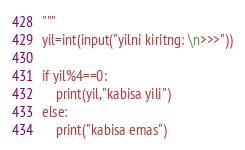Convert code to text. <code><loc_0><loc_0><loc_500><loc_500><_Python_>"""
yil=int(input("yilni kiritng: \n>>>"))

if yil%4==0:
    print(yil,"kabisa yili")
else:
    print("kabisa emas")</code> 